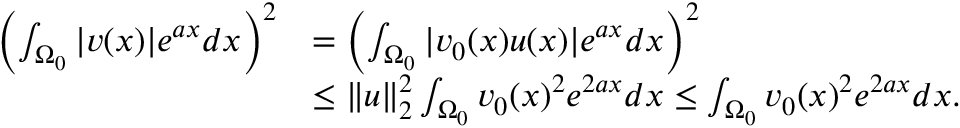<formula> <loc_0><loc_0><loc_500><loc_500>\begin{array} { r l } { \left ( \int _ { \Omega _ { 0 } } | v ( x ) | e ^ { a x } d x \right ) ^ { 2 } } & { = \left ( \int _ { \Omega _ { 0 } } | v _ { 0 } ( x ) u ( x ) | e ^ { a x } d x \right ) ^ { 2 } } \\ & { \leq \| u \| _ { 2 } ^ { 2 } \int _ { \Omega _ { 0 } } v _ { 0 } ( x ) ^ { 2 } e ^ { 2 a x } d x \leq \int _ { \Omega _ { 0 } } v _ { 0 } ( x ) ^ { 2 } e ^ { 2 a x } d x . } \end{array}</formula> 